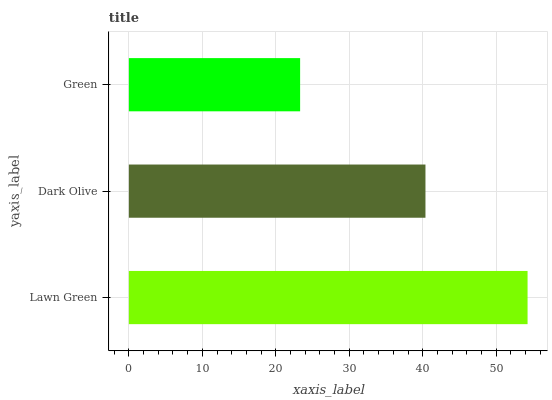Is Green the minimum?
Answer yes or no. Yes. Is Lawn Green the maximum?
Answer yes or no. Yes. Is Dark Olive the minimum?
Answer yes or no. No. Is Dark Olive the maximum?
Answer yes or no. No. Is Lawn Green greater than Dark Olive?
Answer yes or no. Yes. Is Dark Olive less than Lawn Green?
Answer yes or no. Yes. Is Dark Olive greater than Lawn Green?
Answer yes or no. No. Is Lawn Green less than Dark Olive?
Answer yes or no. No. Is Dark Olive the high median?
Answer yes or no. Yes. Is Dark Olive the low median?
Answer yes or no. Yes. Is Green the high median?
Answer yes or no. No. Is Lawn Green the low median?
Answer yes or no. No. 